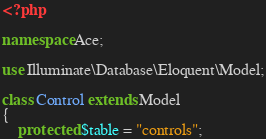<code> <loc_0><loc_0><loc_500><loc_500><_PHP_><?php

namespace Ace;

use Illuminate\Database\Eloquent\Model;

class Control extends Model
{
    protected $table = "controls";
</code> 